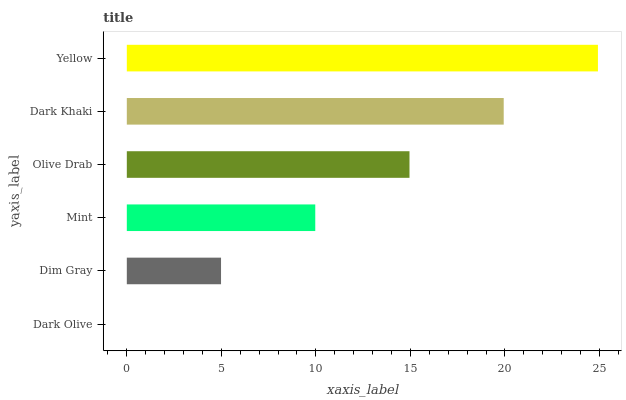Is Dark Olive the minimum?
Answer yes or no. Yes. Is Yellow the maximum?
Answer yes or no. Yes. Is Dim Gray the minimum?
Answer yes or no. No. Is Dim Gray the maximum?
Answer yes or no. No. Is Dim Gray greater than Dark Olive?
Answer yes or no. Yes. Is Dark Olive less than Dim Gray?
Answer yes or no. Yes. Is Dark Olive greater than Dim Gray?
Answer yes or no. No. Is Dim Gray less than Dark Olive?
Answer yes or no. No. Is Olive Drab the high median?
Answer yes or no. Yes. Is Mint the low median?
Answer yes or no. Yes. Is Dark Olive the high median?
Answer yes or no. No. Is Dim Gray the low median?
Answer yes or no. No. 